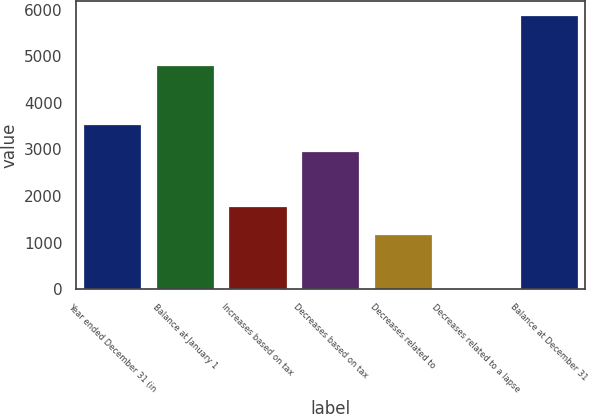Convert chart. <chart><loc_0><loc_0><loc_500><loc_500><bar_chart><fcel>Year ended December 31 (in<fcel>Balance at January 1<fcel>Increases based on tax<fcel>Decreases based on tax<fcel>Decreases related to<fcel>Decreases related to a lapse<fcel>Balance at December 31<nl><fcel>3544<fcel>4811<fcel>1781.5<fcel>2956.5<fcel>1194<fcel>19<fcel>5894<nl></chart> 